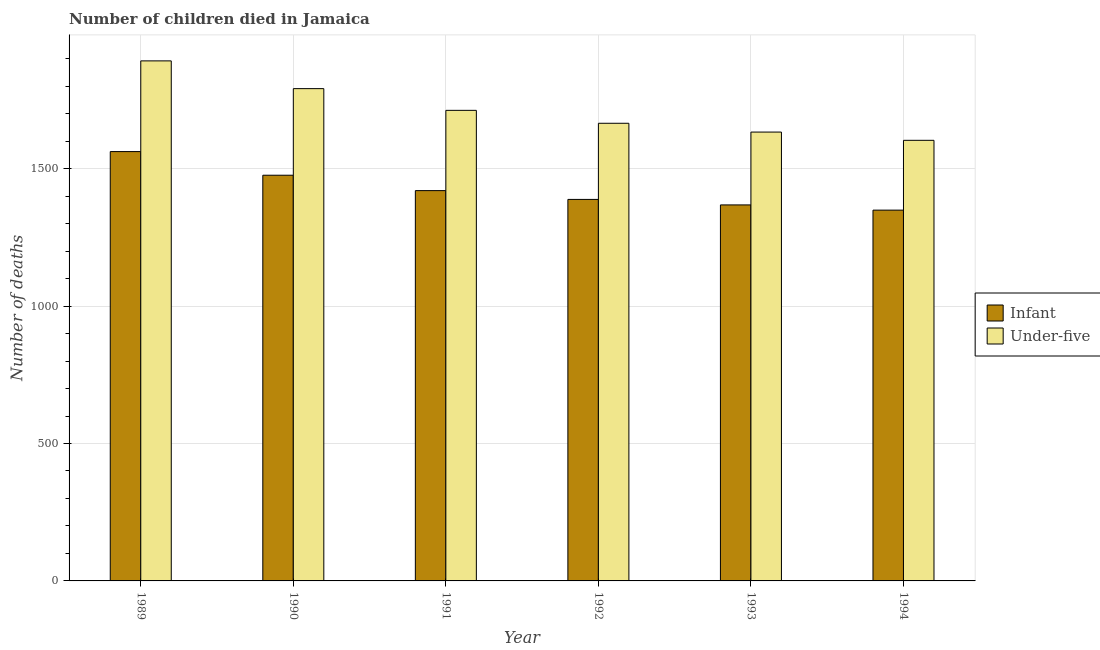How many different coloured bars are there?
Keep it short and to the point. 2. Are the number of bars per tick equal to the number of legend labels?
Your answer should be very brief. Yes. Are the number of bars on each tick of the X-axis equal?
Give a very brief answer. Yes. What is the label of the 3rd group of bars from the left?
Provide a succinct answer. 1991. In how many cases, is the number of bars for a given year not equal to the number of legend labels?
Give a very brief answer. 0. What is the number of under-five deaths in 1994?
Your answer should be very brief. 1603. Across all years, what is the maximum number of infant deaths?
Keep it short and to the point. 1562. Across all years, what is the minimum number of under-five deaths?
Make the answer very short. 1603. In which year was the number of under-five deaths maximum?
Your response must be concise. 1989. What is the total number of under-five deaths in the graph?
Give a very brief answer. 1.03e+04. What is the difference between the number of infant deaths in 1990 and that in 1994?
Your answer should be very brief. 127. What is the difference between the number of infant deaths in 1992 and the number of under-five deaths in 1994?
Provide a short and direct response. 39. What is the average number of under-five deaths per year?
Provide a short and direct response. 1716. In the year 1991, what is the difference between the number of infant deaths and number of under-five deaths?
Keep it short and to the point. 0. What is the ratio of the number of under-five deaths in 1989 to that in 1993?
Keep it short and to the point. 1.16. Is the number of infant deaths in 1989 less than that in 1992?
Offer a terse response. No. Is the difference between the number of infant deaths in 1991 and 1992 greater than the difference between the number of under-five deaths in 1991 and 1992?
Keep it short and to the point. No. What is the difference between the highest and the second highest number of under-five deaths?
Give a very brief answer. 101. What is the difference between the highest and the lowest number of under-five deaths?
Your answer should be very brief. 289. In how many years, is the number of infant deaths greater than the average number of infant deaths taken over all years?
Ensure brevity in your answer.  2. Is the sum of the number of under-five deaths in 1992 and 1994 greater than the maximum number of infant deaths across all years?
Your answer should be very brief. Yes. What does the 2nd bar from the left in 1994 represents?
Offer a terse response. Under-five. What does the 2nd bar from the right in 1989 represents?
Ensure brevity in your answer.  Infant. Are all the bars in the graph horizontal?
Provide a succinct answer. No. What is the difference between two consecutive major ticks on the Y-axis?
Your response must be concise. 500. Are the values on the major ticks of Y-axis written in scientific E-notation?
Keep it short and to the point. No. Does the graph contain grids?
Make the answer very short. Yes. Where does the legend appear in the graph?
Make the answer very short. Center right. How are the legend labels stacked?
Provide a short and direct response. Vertical. What is the title of the graph?
Your answer should be very brief. Number of children died in Jamaica. Does "Largest city" appear as one of the legend labels in the graph?
Give a very brief answer. No. What is the label or title of the Y-axis?
Offer a very short reply. Number of deaths. What is the Number of deaths of Infant in 1989?
Offer a very short reply. 1562. What is the Number of deaths of Under-five in 1989?
Provide a short and direct response. 1892. What is the Number of deaths in Infant in 1990?
Give a very brief answer. 1476. What is the Number of deaths in Under-five in 1990?
Offer a very short reply. 1791. What is the Number of deaths in Infant in 1991?
Offer a very short reply. 1420. What is the Number of deaths of Under-five in 1991?
Provide a short and direct response. 1712. What is the Number of deaths of Infant in 1992?
Make the answer very short. 1388. What is the Number of deaths in Under-five in 1992?
Keep it short and to the point. 1665. What is the Number of deaths of Infant in 1993?
Your answer should be very brief. 1368. What is the Number of deaths of Under-five in 1993?
Make the answer very short. 1633. What is the Number of deaths in Infant in 1994?
Offer a very short reply. 1349. What is the Number of deaths of Under-five in 1994?
Provide a succinct answer. 1603. Across all years, what is the maximum Number of deaths in Infant?
Your response must be concise. 1562. Across all years, what is the maximum Number of deaths in Under-five?
Your answer should be very brief. 1892. Across all years, what is the minimum Number of deaths in Infant?
Give a very brief answer. 1349. Across all years, what is the minimum Number of deaths of Under-five?
Your answer should be very brief. 1603. What is the total Number of deaths of Infant in the graph?
Provide a short and direct response. 8563. What is the total Number of deaths in Under-five in the graph?
Provide a succinct answer. 1.03e+04. What is the difference between the Number of deaths in Under-five in 1989 and that in 1990?
Offer a very short reply. 101. What is the difference between the Number of deaths of Infant in 1989 and that in 1991?
Your response must be concise. 142. What is the difference between the Number of deaths in Under-five in 1989 and that in 1991?
Make the answer very short. 180. What is the difference between the Number of deaths in Infant in 1989 and that in 1992?
Your answer should be compact. 174. What is the difference between the Number of deaths of Under-five in 1989 and that in 1992?
Your response must be concise. 227. What is the difference between the Number of deaths of Infant in 1989 and that in 1993?
Offer a very short reply. 194. What is the difference between the Number of deaths in Under-five in 1989 and that in 1993?
Provide a succinct answer. 259. What is the difference between the Number of deaths of Infant in 1989 and that in 1994?
Offer a very short reply. 213. What is the difference between the Number of deaths in Under-five in 1989 and that in 1994?
Give a very brief answer. 289. What is the difference between the Number of deaths in Under-five in 1990 and that in 1991?
Provide a succinct answer. 79. What is the difference between the Number of deaths in Infant in 1990 and that in 1992?
Provide a short and direct response. 88. What is the difference between the Number of deaths in Under-five in 1990 and that in 1992?
Your answer should be compact. 126. What is the difference between the Number of deaths of Infant in 1990 and that in 1993?
Your response must be concise. 108. What is the difference between the Number of deaths of Under-five in 1990 and that in 1993?
Offer a terse response. 158. What is the difference between the Number of deaths of Infant in 1990 and that in 1994?
Your response must be concise. 127. What is the difference between the Number of deaths in Under-five in 1990 and that in 1994?
Provide a succinct answer. 188. What is the difference between the Number of deaths of Infant in 1991 and that in 1992?
Keep it short and to the point. 32. What is the difference between the Number of deaths in Infant in 1991 and that in 1993?
Your answer should be compact. 52. What is the difference between the Number of deaths in Under-five in 1991 and that in 1993?
Your response must be concise. 79. What is the difference between the Number of deaths of Infant in 1991 and that in 1994?
Make the answer very short. 71. What is the difference between the Number of deaths of Under-five in 1991 and that in 1994?
Offer a very short reply. 109. What is the difference between the Number of deaths in Infant in 1992 and that in 1993?
Provide a short and direct response. 20. What is the difference between the Number of deaths in Infant in 1993 and that in 1994?
Offer a terse response. 19. What is the difference between the Number of deaths of Infant in 1989 and the Number of deaths of Under-five in 1990?
Offer a very short reply. -229. What is the difference between the Number of deaths in Infant in 1989 and the Number of deaths in Under-five in 1991?
Ensure brevity in your answer.  -150. What is the difference between the Number of deaths of Infant in 1989 and the Number of deaths of Under-five in 1992?
Offer a very short reply. -103. What is the difference between the Number of deaths in Infant in 1989 and the Number of deaths in Under-five in 1993?
Keep it short and to the point. -71. What is the difference between the Number of deaths in Infant in 1989 and the Number of deaths in Under-five in 1994?
Make the answer very short. -41. What is the difference between the Number of deaths in Infant in 1990 and the Number of deaths in Under-five in 1991?
Your answer should be very brief. -236. What is the difference between the Number of deaths in Infant in 1990 and the Number of deaths in Under-five in 1992?
Ensure brevity in your answer.  -189. What is the difference between the Number of deaths of Infant in 1990 and the Number of deaths of Under-five in 1993?
Ensure brevity in your answer.  -157. What is the difference between the Number of deaths in Infant in 1990 and the Number of deaths in Under-five in 1994?
Give a very brief answer. -127. What is the difference between the Number of deaths of Infant in 1991 and the Number of deaths of Under-five in 1992?
Your answer should be compact. -245. What is the difference between the Number of deaths of Infant in 1991 and the Number of deaths of Under-five in 1993?
Your response must be concise. -213. What is the difference between the Number of deaths of Infant in 1991 and the Number of deaths of Under-five in 1994?
Make the answer very short. -183. What is the difference between the Number of deaths of Infant in 1992 and the Number of deaths of Under-five in 1993?
Give a very brief answer. -245. What is the difference between the Number of deaths in Infant in 1992 and the Number of deaths in Under-five in 1994?
Your answer should be very brief. -215. What is the difference between the Number of deaths in Infant in 1993 and the Number of deaths in Under-five in 1994?
Offer a very short reply. -235. What is the average Number of deaths of Infant per year?
Your answer should be compact. 1427.17. What is the average Number of deaths in Under-five per year?
Make the answer very short. 1716. In the year 1989, what is the difference between the Number of deaths of Infant and Number of deaths of Under-five?
Keep it short and to the point. -330. In the year 1990, what is the difference between the Number of deaths in Infant and Number of deaths in Under-five?
Offer a terse response. -315. In the year 1991, what is the difference between the Number of deaths in Infant and Number of deaths in Under-five?
Your answer should be very brief. -292. In the year 1992, what is the difference between the Number of deaths in Infant and Number of deaths in Under-five?
Offer a terse response. -277. In the year 1993, what is the difference between the Number of deaths in Infant and Number of deaths in Under-five?
Give a very brief answer. -265. In the year 1994, what is the difference between the Number of deaths in Infant and Number of deaths in Under-five?
Provide a succinct answer. -254. What is the ratio of the Number of deaths in Infant in 1989 to that in 1990?
Provide a short and direct response. 1.06. What is the ratio of the Number of deaths of Under-five in 1989 to that in 1990?
Provide a short and direct response. 1.06. What is the ratio of the Number of deaths of Under-five in 1989 to that in 1991?
Give a very brief answer. 1.11. What is the ratio of the Number of deaths in Infant in 1989 to that in 1992?
Offer a very short reply. 1.13. What is the ratio of the Number of deaths in Under-five in 1989 to that in 1992?
Your response must be concise. 1.14. What is the ratio of the Number of deaths of Infant in 1989 to that in 1993?
Make the answer very short. 1.14. What is the ratio of the Number of deaths in Under-five in 1989 to that in 1993?
Your answer should be compact. 1.16. What is the ratio of the Number of deaths in Infant in 1989 to that in 1994?
Give a very brief answer. 1.16. What is the ratio of the Number of deaths in Under-five in 1989 to that in 1994?
Provide a succinct answer. 1.18. What is the ratio of the Number of deaths of Infant in 1990 to that in 1991?
Provide a succinct answer. 1.04. What is the ratio of the Number of deaths of Under-five in 1990 to that in 1991?
Provide a short and direct response. 1.05. What is the ratio of the Number of deaths in Infant in 1990 to that in 1992?
Offer a terse response. 1.06. What is the ratio of the Number of deaths in Under-five in 1990 to that in 1992?
Your answer should be very brief. 1.08. What is the ratio of the Number of deaths of Infant in 1990 to that in 1993?
Offer a terse response. 1.08. What is the ratio of the Number of deaths of Under-five in 1990 to that in 1993?
Your response must be concise. 1.1. What is the ratio of the Number of deaths of Infant in 1990 to that in 1994?
Give a very brief answer. 1.09. What is the ratio of the Number of deaths in Under-five in 1990 to that in 1994?
Ensure brevity in your answer.  1.12. What is the ratio of the Number of deaths in Infant in 1991 to that in 1992?
Make the answer very short. 1.02. What is the ratio of the Number of deaths of Under-five in 1991 to that in 1992?
Provide a succinct answer. 1.03. What is the ratio of the Number of deaths in Infant in 1991 to that in 1993?
Give a very brief answer. 1.04. What is the ratio of the Number of deaths of Under-five in 1991 to that in 1993?
Offer a very short reply. 1.05. What is the ratio of the Number of deaths of Infant in 1991 to that in 1994?
Provide a succinct answer. 1.05. What is the ratio of the Number of deaths in Under-five in 1991 to that in 1994?
Keep it short and to the point. 1.07. What is the ratio of the Number of deaths of Infant in 1992 to that in 1993?
Your response must be concise. 1.01. What is the ratio of the Number of deaths of Under-five in 1992 to that in 1993?
Make the answer very short. 1.02. What is the ratio of the Number of deaths of Infant in 1992 to that in 1994?
Make the answer very short. 1.03. What is the ratio of the Number of deaths in Under-five in 1992 to that in 1994?
Offer a very short reply. 1.04. What is the ratio of the Number of deaths of Infant in 1993 to that in 1994?
Offer a very short reply. 1.01. What is the ratio of the Number of deaths in Under-five in 1993 to that in 1994?
Offer a very short reply. 1.02. What is the difference between the highest and the second highest Number of deaths of Under-five?
Provide a succinct answer. 101. What is the difference between the highest and the lowest Number of deaths in Infant?
Provide a short and direct response. 213. What is the difference between the highest and the lowest Number of deaths in Under-five?
Make the answer very short. 289. 